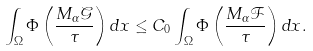Convert formula to latex. <formula><loc_0><loc_0><loc_500><loc_500>\int _ { \Omega } \Phi \left ( \frac { M _ { \alpha } \mathcal { G } } { \tau } \right ) d x & \leq C _ { 0 } \int _ { \Omega } \Phi \left ( \frac { M _ { \alpha } \mathcal { F } } { \tau } \right ) d x .</formula> 